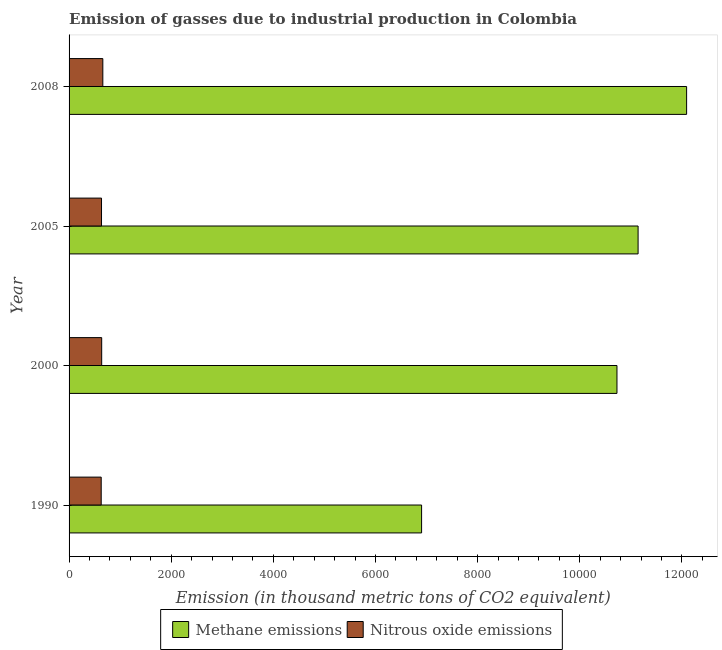How many groups of bars are there?
Your answer should be very brief. 4. Are the number of bars per tick equal to the number of legend labels?
Make the answer very short. Yes. How many bars are there on the 2nd tick from the bottom?
Your answer should be very brief. 2. What is the label of the 1st group of bars from the top?
Provide a succinct answer. 2008. In how many cases, is the number of bars for a given year not equal to the number of legend labels?
Your response must be concise. 0. What is the amount of methane emissions in 1990?
Keep it short and to the point. 6902.6. Across all years, what is the maximum amount of methane emissions?
Offer a very short reply. 1.21e+04. Across all years, what is the minimum amount of methane emissions?
Give a very brief answer. 6902.6. What is the total amount of methane emissions in the graph?
Your answer should be compact. 4.09e+04. What is the difference between the amount of nitrous oxide emissions in 1990 and that in 2008?
Your response must be concise. -32. What is the difference between the amount of methane emissions in 2005 and the amount of nitrous oxide emissions in 2008?
Ensure brevity in your answer.  1.05e+04. What is the average amount of nitrous oxide emissions per year?
Your response must be concise. 641.08. In the year 2008, what is the difference between the amount of nitrous oxide emissions and amount of methane emissions?
Offer a very short reply. -1.14e+04. In how many years, is the amount of nitrous oxide emissions greater than 7200 thousand metric tons?
Keep it short and to the point. 0. Is the difference between the amount of nitrous oxide emissions in 2005 and 2008 greater than the difference between the amount of methane emissions in 2005 and 2008?
Your response must be concise. Yes. What is the difference between the highest and the second highest amount of methane emissions?
Provide a short and direct response. 950. What is the difference between the highest and the lowest amount of methane emissions?
Provide a succinct answer. 5189.3. In how many years, is the amount of nitrous oxide emissions greater than the average amount of nitrous oxide emissions taken over all years?
Your response must be concise. 1. What does the 1st bar from the top in 2008 represents?
Your answer should be compact. Nitrous oxide emissions. What does the 1st bar from the bottom in 2008 represents?
Give a very brief answer. Methane emissions. How many bars are there?
Your answer should be very brief. 8. Are all the bars in the graph horizontal?
Keep it short and to the point. Yes. How many years are there in the graph?
Give a very brief answer. 4. Are the values on the major ticks of X-axis written in scientific E-notation?
Make the answer very short. No. Does the graph contain any zero values?
Keep it short and to the point. No. Where does the legend appear in the graph?
Provide a succinct answer. Bottom center. What is the title of the graph?
Give a very brief answer. Emission of gasses due to industrial production in Colombia. Does "RDB nonconcessional" appear as one of the legend labels in the graph?
Ensure brevity in your answer.  No. What is the label or title of the X-axis?
Your answer should be compact. Emission (in thousand metric tons of CO2 equivalent). What is the Emission (in thousand metric tons of CO2 equivalent) in Methane emissions in 1990?
Keep it short and to the point. 6902.6. What is the Emission (in thousand metric tons of CO2 equivalent) in Nitrous oxide emissions in 1990?
Make the answer very short. 629.1. What is the Emission (in thousand metric tons of CO2 equivalent) in Methane emissions in 2000?
Offer a very short reply. 1.07e+04. What is the Emission (in thousand metric tons of CO2 equivalent) of Nitrous oxide emissions in 2000?
Ensure brevity in your answer.  638.8. What is the Emission (in thousand metric tons of CO2 equivalent) of Methane emissions in 2005?
Ensure brevity in your answer.  1.11e+04. What is the Emission (in thousand metric tons of CO2 equivalent) of Nitrous oxide emissions in 2005?
Keep it short and to the point. 635.3. What is the Emission (in thousand metric tons of CO2 equivalent) in Methane emissions in 2008?
Provide a short and direct response. 1.21e+04. What is the Emission (in thousand metric tons of CO2 equivalent) in Nitrous oxide emissions in 2008?
Ensure brevity in your answer.  661.1. Across all years, what is the maximum Emission (in thousand metric tons of CO2 equivalent) in Methane emissions?
Keep it short and to the point. 1.21e+04. Across all years, what is the maximum Emission (in thousand metric tons of CO2 equivalent) in Nitrous oxide emissions?
Offer a terse response. 661.1. Across all years, what is the minimum Emission (in thousand metric tons of CO2 equivalent) in Methane emissions?
Ensure brevity in your answer.  6902.6. Across all years, what is the minimum Emission (in thousand metric tons of CO2 equivalent) in Nitrous oxide emissions?
Keep it short and to the point. 629.1. What is the total Emission (in thousand metric tons of CO2 equivalent) in Methane emissions in the graph?
Provide a succinct answer. 4.09e+04. What is the total Emission (in thousand metric tons of CO2 equivalent) in Nitrous oxide emissions in the graph?
Provide a succinct answer. 2564.3. What is the difference between the Emission (in thousand metric tons of CO2 equivalent) in Methane emissions in 1990 and that in 2000?
Your answer should be very brief. -3825.6. What is the difference between the Emission (in thousand metric tons of CO2 equivalent) in Methane emissions in 1990 and that in 2005?
Provide a short and direct response. -4239.3. What is the difference between the Emission (in thousand metric tons of CO2 equivalent) in Methane emissions in 1990 and that in 2008?
Offer a terse response. -5189.3. What is the difference between the Emission (in thousand metric tons of CO2 equivalent) of Nitrous oxide emissions in 1990 and that in 2008?
Provide a succinct answer. -32. What is the difference between the Emission (in thousand metric tons of CO2 equivalent) of Methane emissions in 2000 and that in 2005?
Your answer should be very brief. -413.7. What is the difference between the Emission (in thousand metric tons of CO2 equivalent) in Methane emissions in 2000 and that in 2008?
Give a very brief answer. -1363.7. What is the difference between the Emission (in thousand metric tons of CO2 equivalent) of Nitrous oxide emissions in 2000 and that in 2008?
Your answer should be very brief. -22.3. What is the difference between the Emission (in thousand metric tons of CO2 equivalent) in Methane emissions in 2005 and that in 2008?
Provide a succinct answer. -950. What is the difference between the Emission (in thousand metric tons of CO2 equivalent) in Nitrous oxide emissions in 2005 and that in 2008?
Offer a very short reply. -25.8. What is the difference between the Emission (in thousand metric tons of CO2 equivalent) of Methane emissions in 1990 and the Emission (in thousand metric tons of CO2 equivalent) of Nitrous oxide emissions in 2000?
Provide a short and direct response. 6263.8. What is the difference between the Emission (in thousand metric tons of CO2 equivalent) in Methane emissions in 1990 and the Emission (in thousand metric tons of CO2 equivalent) in Nitrous oxide emissions in 2005?
Offer a terse response. 6267.3. What is the difference between the Emission (in thousand metric tons of CO2 equivalent) of Methane emissions in 1990 and the Emission (in thousand metric tons of CO2 equivalent) of Nitrous oxide emissions in 2008?
Give a very brief answer. 6241.5. What is the difference between the Emission (in thousand metric tons of CO2 equivalent) of Methane emissions in 2000 and the Emission (in thousand metric tons of CO2 equivalent) of Nitrous oxide emissions in 2005?
Make the answer very short. 1.01e+04. What is the difference between the Emission (in thousand metric tons of CO2 equivalent) of Methane emissions in 2000 and the Emission (in thousand metric tons of CO2 equivalent) of Nitrous oxide emissions in 2008?
Your answer should be very brief. 1.01e+04. What is the difference between the Emission (in thousand metric tons of CO2 equivalent) of Methane emissions in 2005 and the Emission (in thousand metric tons of CO2 equivalent) of Nitrous oxide emissions in 2008?
Give a very brief answer. 1.05e+04. What is the average Emission (in thousand metric tons of CO2 equivalent) in Methane emissions per year?
Give a very brief answer. 1.02e+04. What is the average Emission (in thousand metric tons of CO2 equivalent) of Nitrous oxide emissions per year?
Keep it short and to the point. 641.08. In the year 1990, what is the difference between the Emission (in thousand metric tons of CO2 equivalent) in Methane emissions and Emission (in thousand metric tons of CO2 equivalent) in Nitrous oxide emissions?
Ensure brevity in your answer.  6273.5. In the year 2000, what is the difference between the Emission (in thousand metric tons of CO2 equivalent) in Methane emissions and Emission (in thousand metric tons of CO2 equivalent) in Nitrous oxide emissions?
Your response must be concise. 1.01e+04. In the year 2005, what is the difference between the Emission (in thousand metric tons of CO2 equivalent) in Methane emissions and Emission (in thousand metric tons of CO2 equivalent) in Nitrous oxide emissions?
Provide a succinct answer. 1.05e+04. In the year 2008, what is the difference between the Emission (in thousand metric tons of CO2 equivalent) of Methane emissions and Emission (in thousand metric tons of CO2 equivalent) of Nitrous oxide emissions?
Make the answer very short. 1.14e+04. What is the ratio of the Emission (in thousand metric tons of CO2 equivalent) in Methane emissions in 1990 to that in 2000?
Keep it short and to the point. 0.64. What is the ratio of the Emission (in thousand metric tons of CO2 equivalent) in Methane emissions in 1990 to that in 2005?
Your answer should be compact. 0.62. What is the ratio of the Emission (in thousand metric tons of CO2 equivalent) of Nitrous oxide emissions in 1990 to that in 2005?
Your answer should be compact. 0.99. What is the ratio of the Emission (in thousand metric tons of CO2 equivalent) in Methane emissions in 1990 to that in 2008?
Provide a succinct answer. 0.57. What is the ratio of the Emission (in thousand metric tons of CO2 equivalent) of Nitrous oxide emissions in 1990 to that in 2008?
Offer a terse response. 0.95. What is the ratio of the Emission (in thousand metric tons of CO2 equivalent) in Methane emissions in 2000 to that in 2005?
Offer a very short reply. 0.96. What is the ratio of the Emission (in thousand metric tons of CO2 equivalent) in Methane emissions in 2000 to that in 2008?
Offer a terse response. 0.89. What is the ratio of the Emission (in thousand metric tons of CO2 equivalent) of Nitrous oxide emissions in 2000 to that in 2008?
Ensure brevity in your answer.  0.97. What is the ratio of the Emission (in thousand metric tons of CO2 equivalent) of Methane emissions in 2005 to that in 2008?
Your answer should be compact. 0.92. What is the difference between the highest and the second highest Emission (in thousand metric tons of CO2 equivalent) in Methane emissions?
Your response must be concise. 950. What is the difference between the highest and the second highest Emission (in thousand metric tons of CO2 equivalent) in Nitrous oxide emissions?
Give a very brief answer. 22.3. What is the difference between the highest and the lowest Emission (in thousand metric tons of CO2 equivalent) in Methane emissions?
Make the answer very short. 5189.3. 